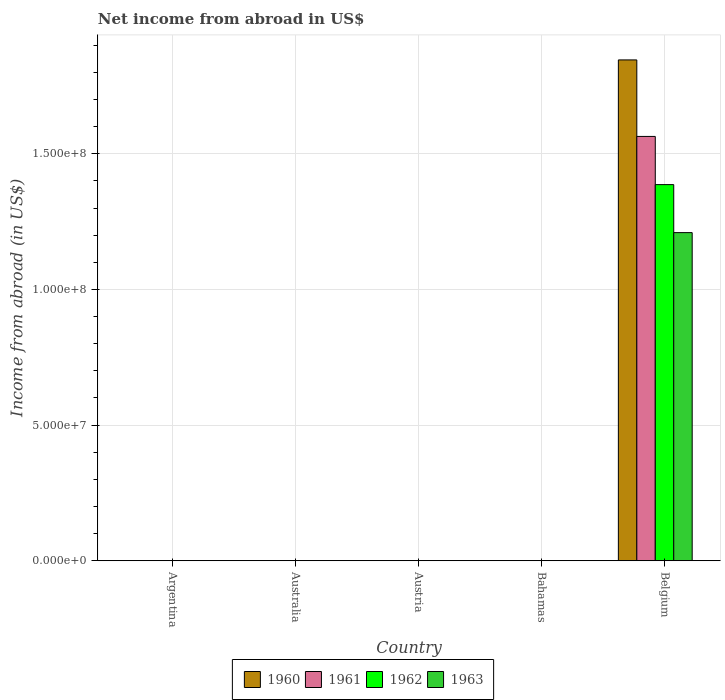Are the number of bars per tick equal to the number of legend labels?
Ensure brevity in your answer.  No. Are the number of bars on each tick of the X-axis equal?
Offer a very short reply. No. How many bars are there on the 4th tick from the left?
Give a very brief answer. 0. What is the label of the 2nd group of bars from the left?
Keep it short and to the point. Australia. In how many cases, is the number of bars for a given country not equal to the number of legend labels?
Keep it short and to the point. 3. What is the net income from abroad in 1961 in Bahamas?
Provide a short and direct response. 0. Across all countries, what is the maximum net income from abroad in 1962?
Make the answer very short. 1.39e+08. What is the total net income from abroad in 1963 in the graph?
Give a very brief answer. 1.21e+08. What is the difference between the net income from abroad in 1961 in Argentina and that in Belgium?
Your response must be concise. -1.56e+08. What is the difference between the net income from abroad in 1961 in Bahamas and the net income from abroad in 1962 in Argentina?
Your answer should be very brief. -0.01. What is the average net income from abroad in 1962 per country?
Your answer should be very brief. 2.77e+07. What is the difference between the net income from abroad of/in 1961 and net income from abroad of/in 1960 in Belgium?
Provide a succinct answer. -2.82e+07. In how many countries, is the net income from abroad in 1961 greater than 140000000 US$?
Give a very brief answer. 1. What is the ratio of the net income from abroad in 1963 in Argentina to that in Belgium?
Offer a terse response. 5.423392505990382e-11. What is the difference between the highest and the lowest net income from abroad in 1963?
Make the answer very short. 1.21e+08. In how many countries, is the net income from abroad in 1963 greater than the average net income from abroad in 1963 taken over all countries?
Ensure brevity in your answer.  1. Are all the bars in the graph horizontal?
Give a very brief answer. No. What is the difference between two consecutive major ticks on the Y-axis?
Your answer should be compact. 5.00e+07. Does the graph contain any zero values?
Your answer should be compact. Yes. Does the graph contain grids?
Your response must be concise. Yes. Where does the legend appear in the graph?
Ensure brevity in your answer.  Bottom center. What is the title of the graph?
Give a very brief answer. Net income from abroad in US$. What is the label or title of the X-axis?
Your response must be concise. Country. What is the label or title of the Y-axis?
Offer a very short reply. Income from abroad (in US$). What is the Income from abroad (in US$) in 1960 in Argentina?
Give a very brief answer. 0. What is the Income from abroad (in US$) of 1961 in Argentina?
Your answer should be very brief. 0. What is the Income from abroad (in US$) in 1962 in Argentina?
Offer a terse response. 0.01. What is the Income from abroad (in US$) of 1963 in Argentina?
Your response must be concise. 0.01. What is the Income from abroad (in US$) in 1960 in Australia?
Your response must be concise. 0. What is the Income from abroad (in US$) of 1962 in Australia?
Offer a very short reply. 0. What is the Income from abroad (in US$) in 1963 in Australia?
Your answer should be compact. 0. What is the Income from abroad (in US$) in 1960 in Bahamas?
Offer a very short reply. 0. What is the Income from abroad (in US$) of 1961 in Bahamas?
Offer a very short reply. 0. What is the Income from abroad (in US$) in 1963 in Bahamas?
Your answer should be very brief. 0. What is the Income from abroad (in US$) in 1960 in Belgium?
Offer a very short reply. 1.85e+08. What is the Income from abroad (in US$) of 1961 in Belgium?
Your response must be concise. 1.56e+08. What is the Income from abroad (in US$) in 1962 in Belgium?
Provide a succinct answer. 1.39e+08. What is the Income from abroad (in US$) in 1963 in Belgium?
Keep it short and to the point. 1.21e+08. Across all countries, what is the maximum Income from abroad (in US$) in 1960?
Make the answer very short. 1.85e+08. Across all countries, what is the maximum Income from abroad (in US$) of 1961?
Your answer should be very brief. 1.56e+08. Across all countries, what is the maximum Income from abroad (in US$) of 1962?
Offer a terse response. 1.39e+08. Across all countries, what is the maximum Income from abroad (in US$) of 1963?
Ensure brevity in your answer.  1.21e+08. Across all countries, what is the minimum Income from abroad (in US$) in 1960?
Offer a very short reply. 0. What is the total Income from abroad (in US$) of 1960 in the graph?
Make the answer very short. 1.85e+08. What is the total Income from abroad (in US$) in 1961 in the graph?
Your response must be concise. 1.56e+08. What is the total Income from abroad (in US$) of 1962 in the graph?
Make the answer very short. 1.39e+08. What is the total Income from abroad (in US$) of 1963 in the graph?
Offer a very short reply. 1.21e+08. What is the difference between the Income from abroad (in US$) of 1960 in Argentina and that in Belgium?
Your answer should be compact. -1.85e+08. What is the difference between the Income from abroad (in US$) of 1961 in Argentina and that in Belgium?
Your answer should be compact. -1.56e+08. What is the difference between the Income from abroad (in US$) of 1962 in Argentina and that in Belgium?
Provide a succinct answer. -1.39e+08. What is the difference between the Income from abroad (in US$) of 1963 in Argentina and that in Belgium?
Your answer should be very brief. -1.21e+08. What is the difference between the Income from abroad (in US$) in 1960 in Argentina and the Income from abroad (in US$) in 1961 in Belgium?
Your answer should be compact. -1.56e+08. What is the difference between the Income from abroad (in US$) in 1960 in Argentina and the Income from abroad (in US$) in 1962 in Belgium?
Offer a terse response. -1.39e+08. What is the difference between the Income from abroad (in US$) of 1960 in Argentina and the Income from abroad (in US$) of 1963 in Belgium?
Give a very brief answer. -1.21e+08. What is the difference between the Income from abroad (in US$) of 1961 in Argentina and the Income from abroad (in US$) of 1962 in Belgium?
Provide a short and direct response. -1.39e+08. What is the difference between the Income from abroad (in US$) of 1961 in Argentina and the Income from abroad (in US$) of 1963 in Belgium?
Your answer should be compact. -1.21e+08. What is the difference between the Income from abroad (in US$) of 1962 in Argentina and the Income from abroad (in US$) of 1963 in Belgium?
Offer a very short reply. -1.21e+08. What is the average Income from abroad (in US$) in 1960 per country?
Offer a very short reply. 3.69e+07. What is the average Income from abroad (in US$) in 1961 per country?
Your answer should be compact. 3.13e+07. What is the average Income from abroad (in US$) in 1962 per country?
Make the answer very short. 2.77e+07. What is the average Income from abroad (in US$) in 1963 per country?
Make the answer very short. 2.42e+07. What is the difference between the Income from abroad (in US$) of 1960 and Income from abroad (in US$) of 1961 in Argentina?
Your response must be concise. -0. What is the difference between the Income from abroad (in US$) of 1960 and Income from abroad (in US$) of 1962 in Argentina?
Your response must be concise. -0. What is the difference between the Income from abroad (in US$) of 1960 and Income from abroad (in US$) of 1963 in Argentina?
Ensure brevity in your answer.  -0. What is the difference between the Income from abroad (in US$) of 1961 and Income from abroad (in US$) of 1962 in Argentina?
Provide a succinct answer. -0. What is the difference between the Income from abroad (in US$) of 1961 and Income from abroad (in US$) of 1963 in Argentina?
Offer a terse response. -0. What is the difference between the Income from abroad (in US$) of 1962 and Income from abroad (in US$) of 1963 in Argentina?
Your answer should be compact. -0. What is the difference between the Income from abroad (in US$) in 1960 and Income from abroad (in US$) in 1961 in Belgium?
Give a very brief answer. 2.82e+07. What is the difference between the Income from abroad (in US$) in 1960 and Income from abroad (in US$) in 1962 in Belgium?
Give a very brief answer. 4.60e+07. What is the difference between the Income from abroad (in US$) of 1960 and Income from abroad (in US$) of 1963 in Belgium?
Provide a succinct answer. 6.37e+07. What is the difference between the Income from abroad (in US$) in 1961 and Income from abroad (in US$) in 1962 in Belgium?
Your response must be concise. 1.78e+07. What is the difference between the Income from abroad (in US$) of 1961 and Income from abroad (in US$) of 1963 in Belgium?
Ensure brevity in your answer.  3.55e+07. What is the difference between the Income from abroad (in US$) in 1962 and Income from abroad (in US$) in 1963 in Belgium?
Give a very brief answer. 1.77e+07. What is the ratio of the Income from abroad (in US$) in 1960 in Argentina to that in Belgium?
Give a very brief answer. 0. What is the ratio of the Income from abroad (in US$) in 1962 in Argentina to that in Belgium?
Offer a very short reply. 0. What is the difference between the highest and the lowest Income from abroad (in US$) of 1960?
Your answer should be compact. 1.85e+08. What is the difference between the highest and the lowest Income from abroad (in US$) of 1961?
Keep it short and to the point. 1.56e+08. What is the difference between the highest and the lowest Income from abroad (in US$) of 1962?
Keep it short and to the point. 1.39e+08. What is the difference between the highest and the lowest Income from abroad (in US$) of 1963?
Your response must be concise. 1.21e+08. 